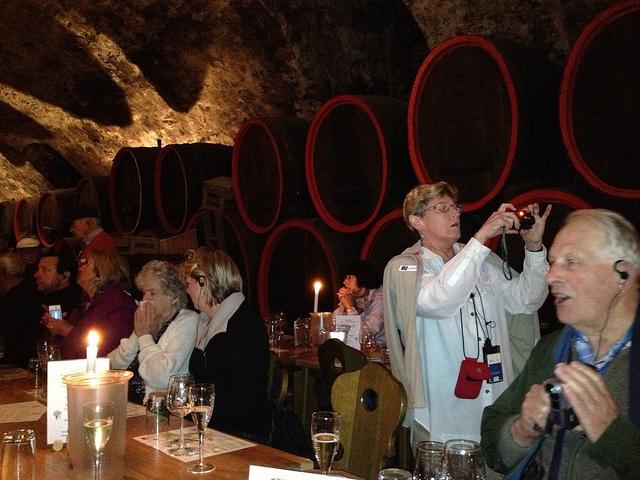Is there a bottle of champagne on the bar?
Short answer required. No. What type of place would this be?
Quick response, please. Restaurant. Since these people are wearing headphones, is this a guided tour?
Keep it brief. No. Is everyone drinking champagne?
Short answer required. No. 